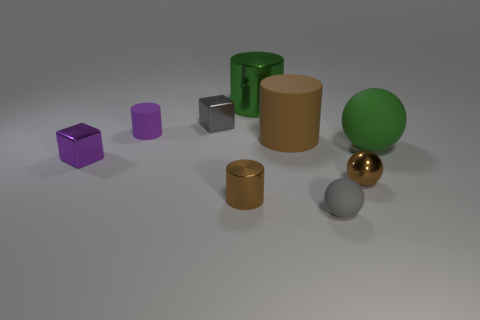There is a gray thing in front of the tiny metal sphere; are there any brown things that are on the right side of it?
Ensure brevity in your answer.  Yes. How many objects are either yellow metal spheres or cylinders?
Give a very brief answer. 4. What shape is the large object that is both in front of the big green metal cylinder and on the left side of the brown ball?
Ensure brevity in your answer.  Cylinder. Does the tiny cylinder behind the big brown cylinder have the same material as the large brown cylinder?
Your answer should be compact. Yes. How many objects are either big brown cylinders or balls that are on the left side of the small brown metallic ball?
Ensure brevity in your answer.  2. There is another cube that is the same material as the small gray block; what color is it?
Make the answer very short. Purple. What number of small balls have the same material as the green cylinder?
Provide a short and direct response. 1. How many brown objects are there?
Make the answer very short. 3. There is a matte cylinder to the left of the big brown rubber object; is its color the same as the metal block in front of the large green rubber sphere?
Give a very brief answer. Yes. What number of gray metallic objects are in front of the brown rubber cylinder?
Provide a short and direct response. 0. 